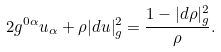Convert formula to latex. <formula><loc_0><loc_0><loc_500><loc_500>2 g ^ { 0 \alpha } u _ { \alpha } + \rho | d u | _ { g } ^ { 2 } = \frac { 1 - | d \rho | _ { g } ^ { 2 } } { \rho } .</formula> 